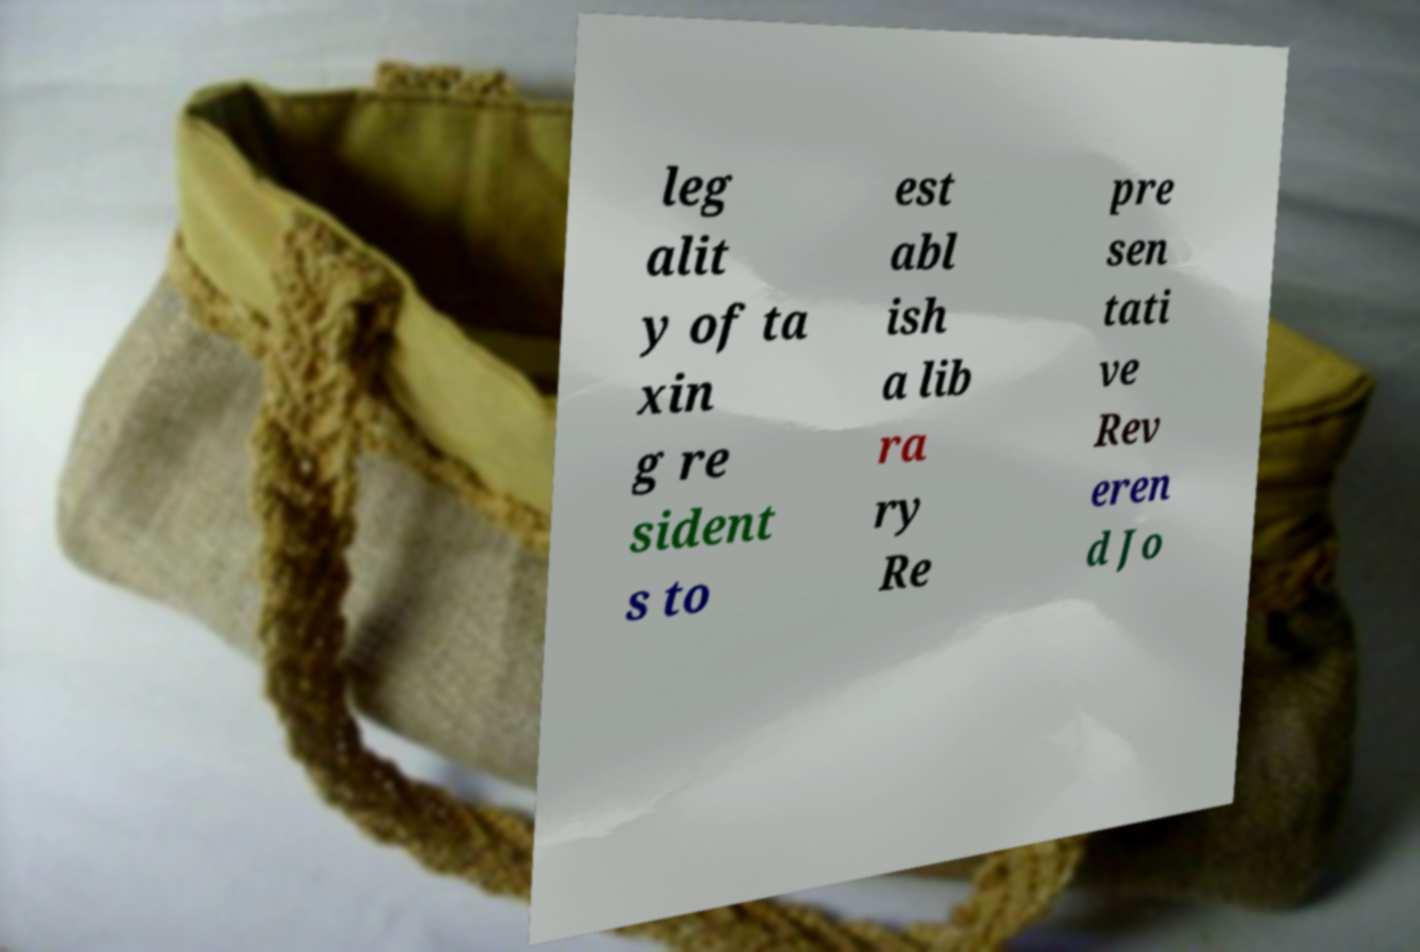There's text embedded in this image that I need extracted. Can you transcribe it verbatim? leg alit y of ta xin g re sident s to est abl ish a lib ra ry Re pre sen tati ve Rev eren d Jo 